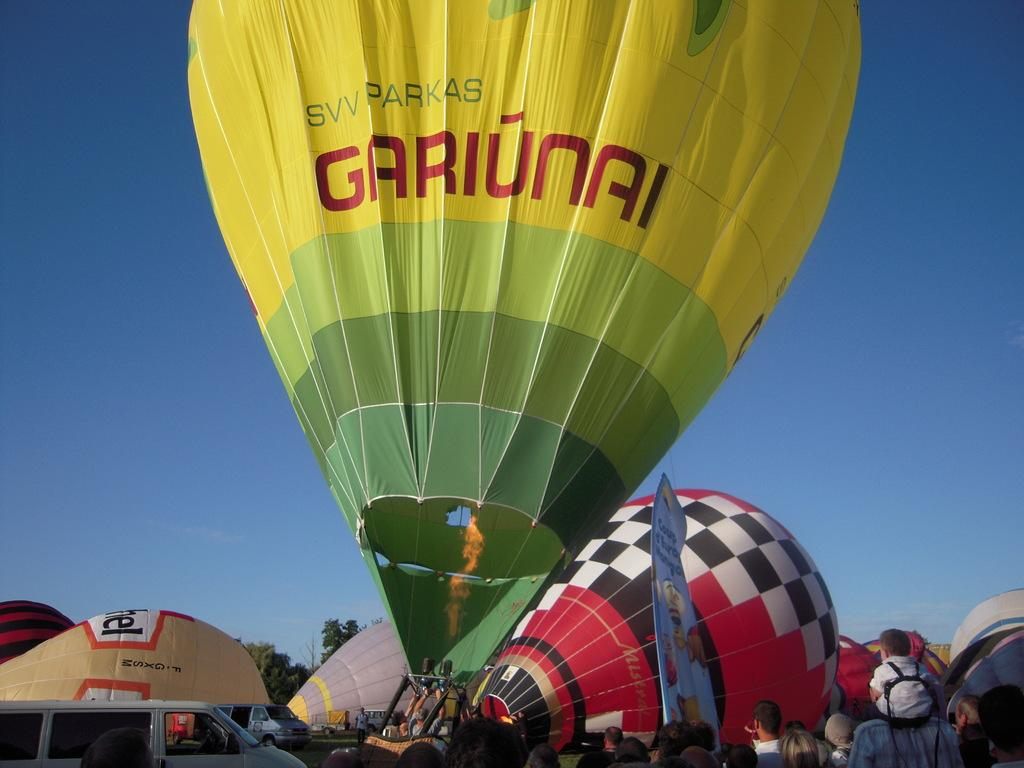What can be seen in the image related to aerial activities? There are parachutes in the image. Are there any people associated with the parachutes? Yes, there are people near the parachutes. What else is present near the parachutes? There is a banner near the parachutes. What can be seen on the ground in the image? There are vehicles on the ground in the image. What type of natural scenery is visible in the background of the image? There are trees in the background of the image. What is visible in the sky in the image? The sky is visible in the background of the image. What type of grain is being harvested in the image? There is no grain or harvesting activity visible in the image. 